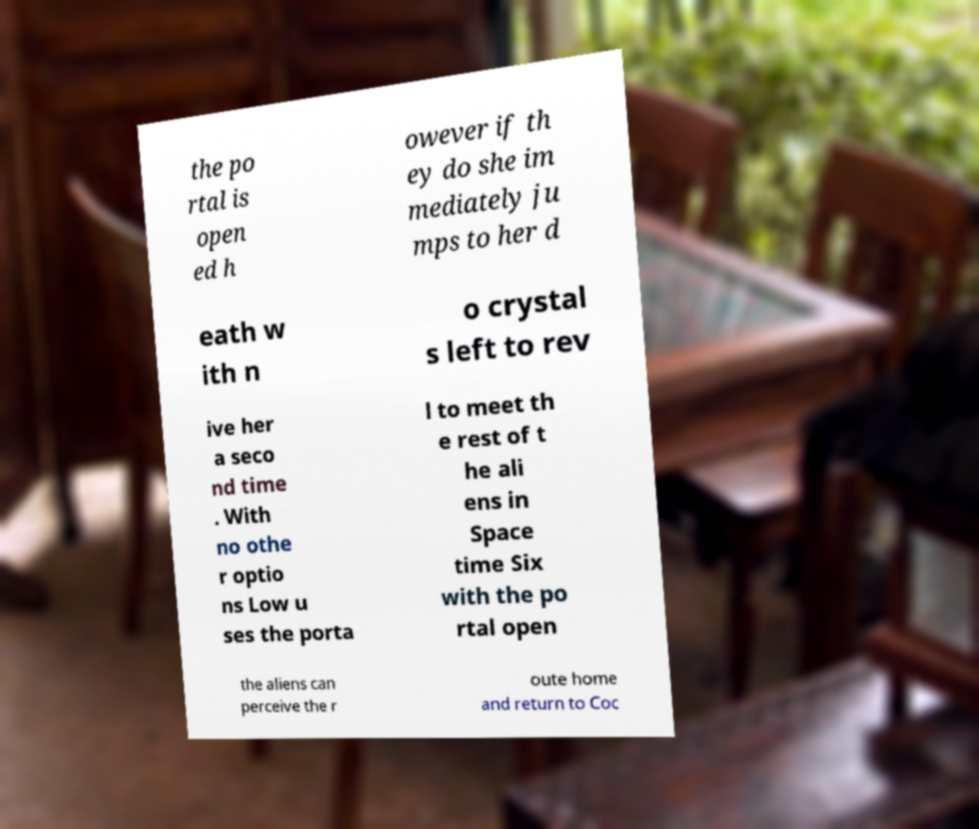Please identify and transcribe the text found in this image. the po rtal is open ed h owever if th ey do she im mediately ju mps to her d eath w ith n o crystal s left to rev ive her a seco nd time . With no othe r optio ns Low u ses the porta l to meet th e rest of t he ali ens in Space time Six with the po rtal open the aliens can perceive the r oute home and return to Coc 